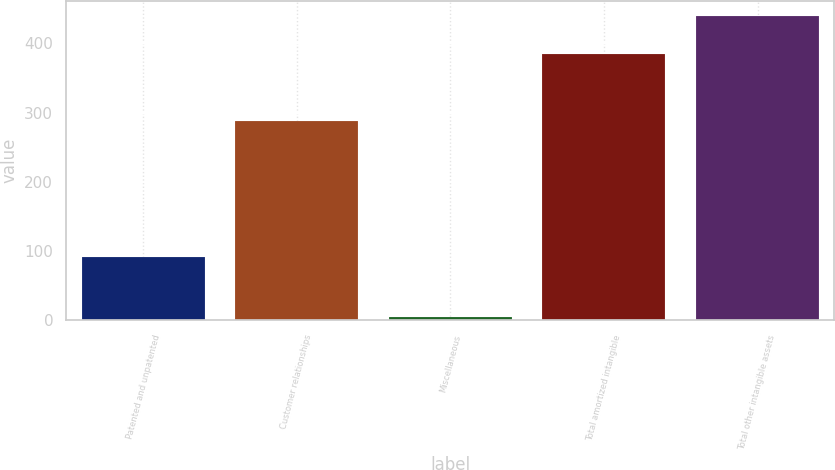Convert chart. <chart><loc_0><loc_0><loc_500><loc_500><bar_chart><fcel>Patented and unpatented<fcel>Customer relationships<fcel>Miscellaneous<fcel>Total amortized intangible<fcel>Total other intangible assets<nl><fcel>91.2<fcel>288.5<fcel>4.4<fcel>384.1<fcel>439.5<nl></chart> 